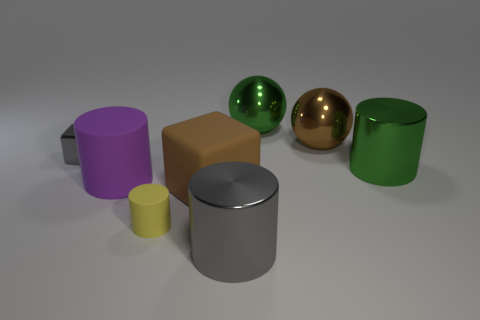Which objects in the image reflect their surroundings the most? The two spheres, one green and one bronze, exhibit the highest degree of reflectivity, each displaying clear reflections of their environment. 